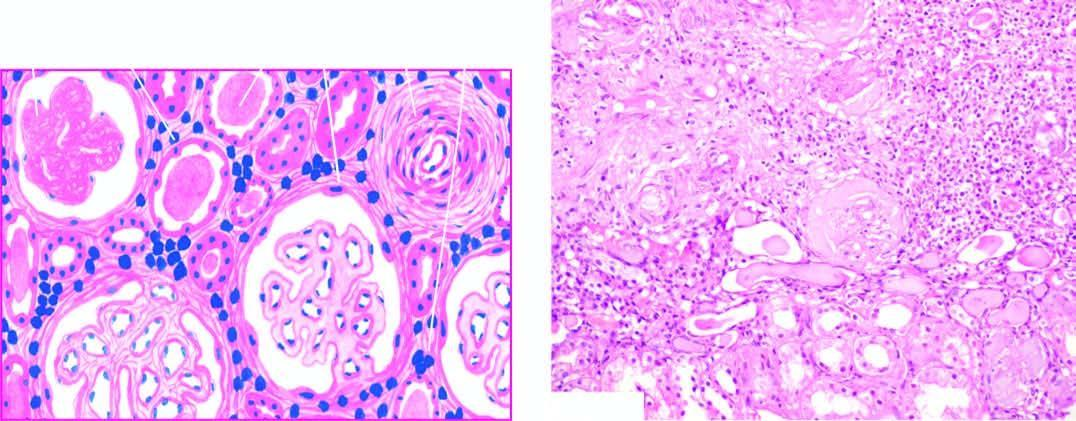does the scarred area show atrophy of some tubules and dilatation of others which contain colloid casts thyroidisation?
Answer the question using a single word or phrase. Yes 